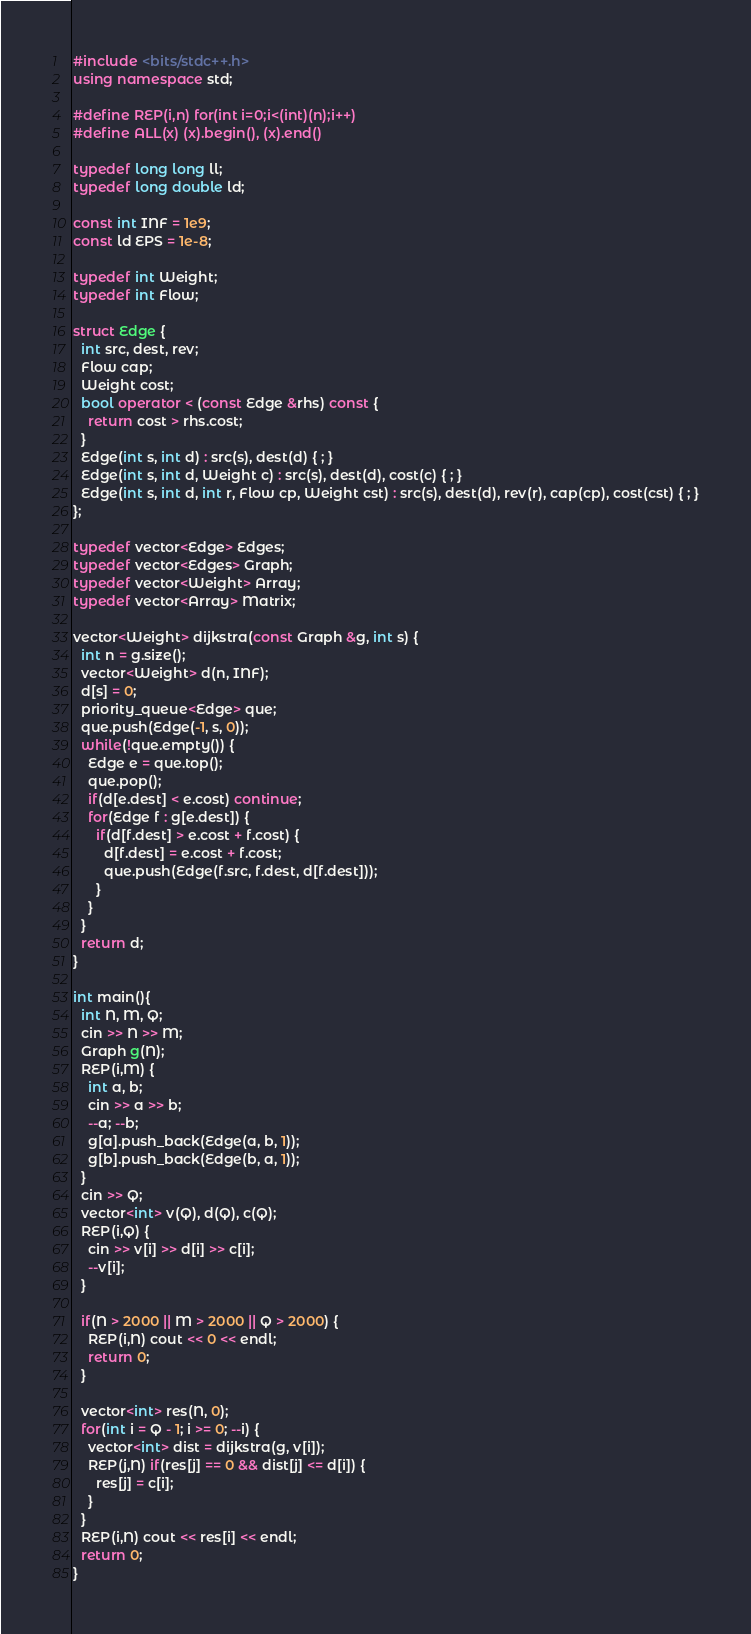<code> <loc_0><loc_0><loc_500><loc_500><_C++_>#include <bits/stdc++.h>
using namespace std;

#define REP(i,n) for(int i=0;i<(int)(n);i++)
#define ALL(x) (x).begin(), (x).end()

typedef long long ll;
typedef long double ld;

const int INF = 1e9;
const ld EPS = 1e-8;

typedef int Weight;
typedef int Flow;

struct Edge {
  int src, dest, rev;
  Flow cap;
  Weight cost;
  bool operator < (const Edge &rhs) const {
    return cost > rhs.cost;
  }
  Edge(int s, int d) : src(s), dest(d) { ; }
  Edge(int s, int d, Weight c) : src(s), dest(d), cost(c) { ; }
  Edge(int s, int d, int r, Flow cp, Weight cst) : src(s), dest(d), rev(r), cap(cp), cost(cst) { ; }
};

typedef vector<Edge> Edges;
typedef vector<Edges> Graph;
typedef vector<Weight> Array;
typedef vector<Array> Matrix;

vector<Weight> dijkstra(const Graph &g, int s) {
  int n = g.size();
  vector<Weight> d(n, INF);
  d[s] = 0;
  priority_queue<Edge> que;
  que.push(Edge(-1, s, 0));
  while(!que.empty()) {
    Edge e = que.top();
    que.pop();
    if(d[e.dest] < e.cost) continue;
    for(Edge f : g[e.dest]) {
      if(d[f.dest] > e.cost + f.cost) {
        d[f.dest] = e.cost + f.cost;
        que.push(Edge(f.src, f.dest, d[f.dest]));
      }
    }
  }
  return d;
}

int main(){
  int N, M, Q;
  cin >> N >> M;
  Graph g(N);
  REP(i,M) {
    int a, b;
    cin >> a >> b;
    --a; --b;
    g[a].push_back(Edge(a, b, 1));
    g[b].push_back(Edge(b, a, 1));
  }
  cin >> Q;
  vector<int> v(Q), d(Q), c(Q);
  REP(i,Q) {
    cin >> v[i] >> d[i] >> c[i];
    --v[i];
  }

  if(N > 2000 || M > 2000 || Q > 2000) {
    REP(i,N) cout << 0 << endl;
    return 0;
  }

  vector<int> res(N, 0);
  for(int i = Q - 1; i >= 0; --i) {
    vector<int> dist = dijkstra(g, v[i]);
    REP(j,N) if(res[j] == 0 && dist[j] <= d[i]) {
      res[j] = c[i];
    }
  }
  REP(i,N) cout << res[i] << endl;
  return 0;
}

</code> 